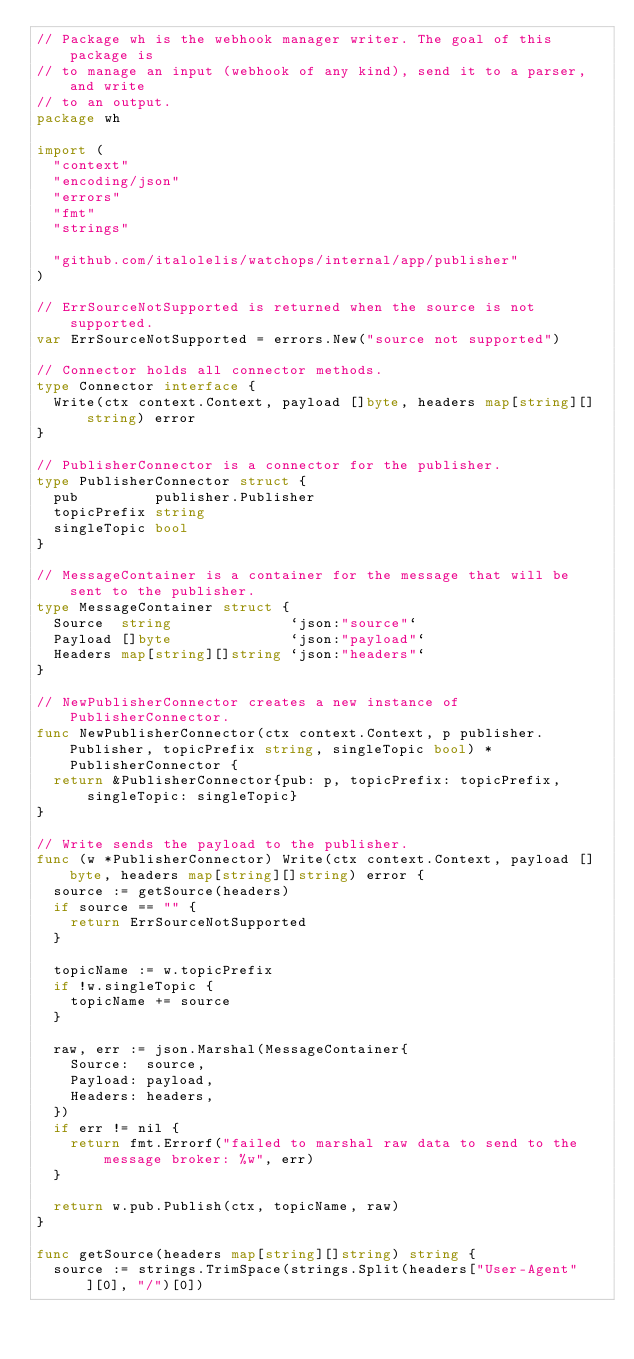<code> <loc_0><loc_0><loc_500><loc_500><_Go_>// Package wh is the webhook manager writer. The goal of this package is
// to manage an input (webhook of any kind), send it to a parser, and write
// to an output.
package wh

import (
	"context"
	"encoding/json"
	"errors"
	"fmt"
	"strings"

	"github.com/italolelis/watchops/internal/app/publisher"
)

// ErrSourceNotSupported is returned when the source is not supported.
var ErrSourceNotSupported = errors.New("source not supported")

// Connector holds all connector methods.
type Connector interface {
	Write(ctx context.Context, payload []byte, headers map[string][]string) error
}

// PublisherConnector is a connector for the publisher.
type PublisherConnector struct {
	pub         publisher.Publisher
	topicPrefix string
	singleTopic bool
}

// MessageContainer is a container for the message that will be sent to the publisher.
type MessageContainer struct {
	Source  string              `json:"source"`
	Payload []byte              `json:"payload"`
	Headers map[string][]string `json:"headers"`
}

// NewPublisherConnector creates a new instance of PublisherConnector.
func NewPublisherConnector(ctx context.Context, p publisher.Publisher, topicPrefix string, singleTopic bool) *PublisherConnector {
	return &PublisherConnector{pub: p, topicPrefix: topicPrefix, singleTopic: singleTopic}
}

// Write sends the payload to the publisher.
func (w *PublisherConnector) Write(ctx context.Context, payload []byte, headers map[string][]string) error {
	source := getSource(headers)
	if source == "" {
		return ErrSourceNotSupported
	}

	topicName := w.topicPrefix
	if !w.singleTopic {
		topicName += source
	}

	raw, err := json.Marshal(MessageContainer{
		Source:  source,
		Payload: payload,
		Headers: headers,
	})
	if err != nil {
		return fmt.Errorf("failed to marshal raw data to send to the message broker: %w", err)
	}

	return w.pub.Publish(ctx, topicName, raw)
}

func getSource(headers map[string][]string) string {
	source := strings.TrimSpace(strings.Split(headers["User-Agent"][0], "/")[0])
</code> 